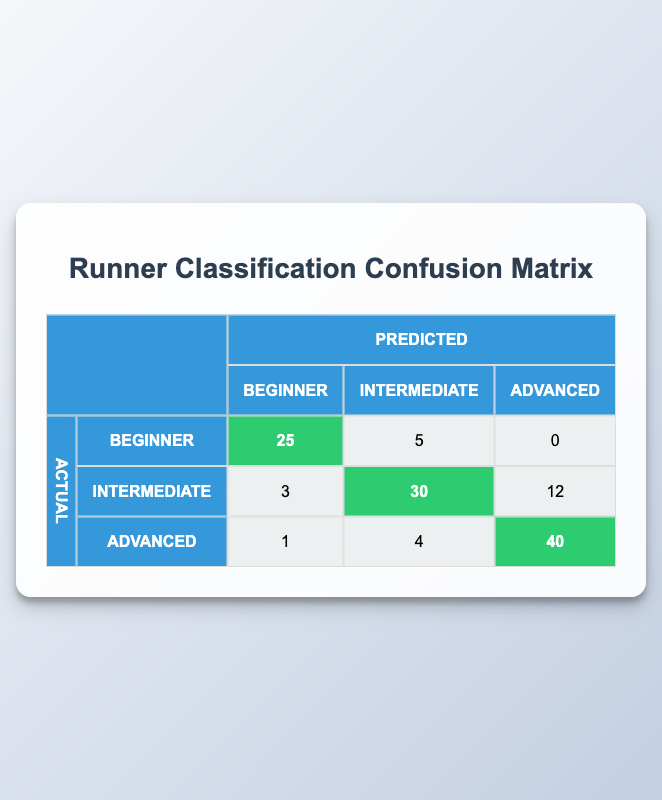What is the number of runners classified as "Advanced" and predicted to be "Advanced"? From the table, the row for "Actual: Advanced" and "Predicted: Advanced" has the count of 40.
Answer: 40 How many runners were actually "Beginner" but predicted to be "Intermediate"? The table shows that 5 runners who were actually "Beginner" were predicted as "Intermediate".
Answer: 5 What is the total number of "Intermediate" runners that were correctly classified? The total for "Intermediate" runners correctly classified is found by looking at the count of "Actual: Intermediate" and "Predicted: Intermediate", which is 30.
Answer: 30 Was there any runner classified as "Advanced" that was predicted to be "Beginner"? Looking at the table, there was indeed 1 runner classified as "Advanced" but predicted as "Beginner".
Answer: Yes What is the total count of instances where "Beginner" runners were misclassified? To find this, we need to add the counts for "Beginner" that were predicted as "Intermediate" (5) and "Advanced" (0), resulting in 5 misclassifications.
Answer: 5 How many more "Advanced" runners were correctly classified compared to "Beginner" runners? The correctly classified "Advanced" runners are 40, and "Beginner" runners are 25. The difference is 40 - 25 = 15.
Answer: 15 What percentage of "Intermediate" runners were misclassified? The total actual counts for "Intermediate" runners is 45 (3+30+12), and 15 were misclassified (3 + 12), so the percentage is 15/45 * 100 = 33.33%.
Answer: 33.33% What is the combined total for all predictions made for "Intermediate" runners? For "Intermediate" runners, the counts are 3 (predicted as Beginner), 30 (predicted as Intermediate), and 12 (predicted as Advanced), totaling 3 + 30 + 12 = 45.
Answer: 45 How many predictions were made for runners classified as "Beginner"? The predictions for "Beginner" runners include 25 (correctly classified) and 5 (predicted as Intermediate), summing up to 30 predictions.
Answer: 30 